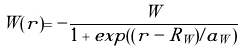<formula> <loc_0><loc_0><loc_500><loc_500>W ( r ) = - \frac { W } { 1 + e x p ( ( r - R _ { W } ) / a _ { W } ) }</formula> 